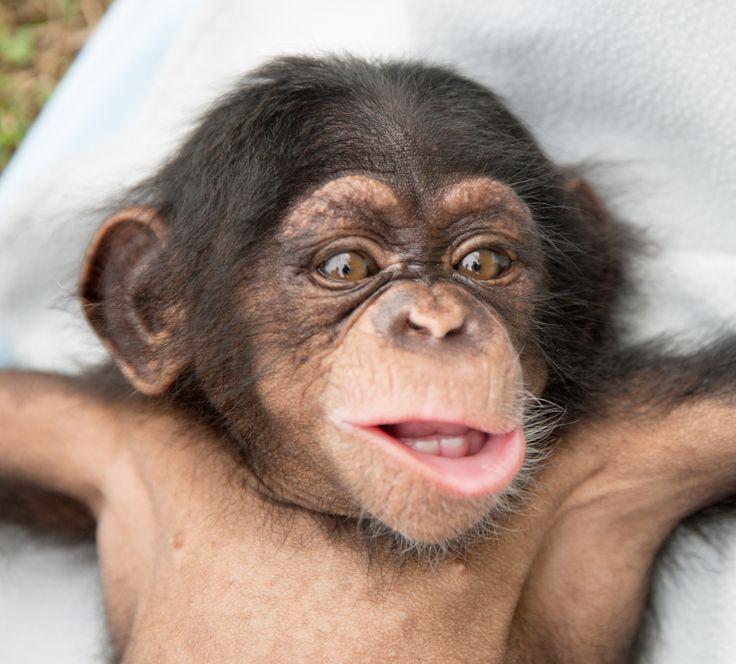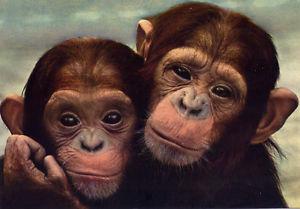The first image is the image on the left, the second image is the image on the right. For the images displayed, is the sentence "In one image of each pair two chimpanzees are hugging." factually correct? Answer yes or no. Yes. 